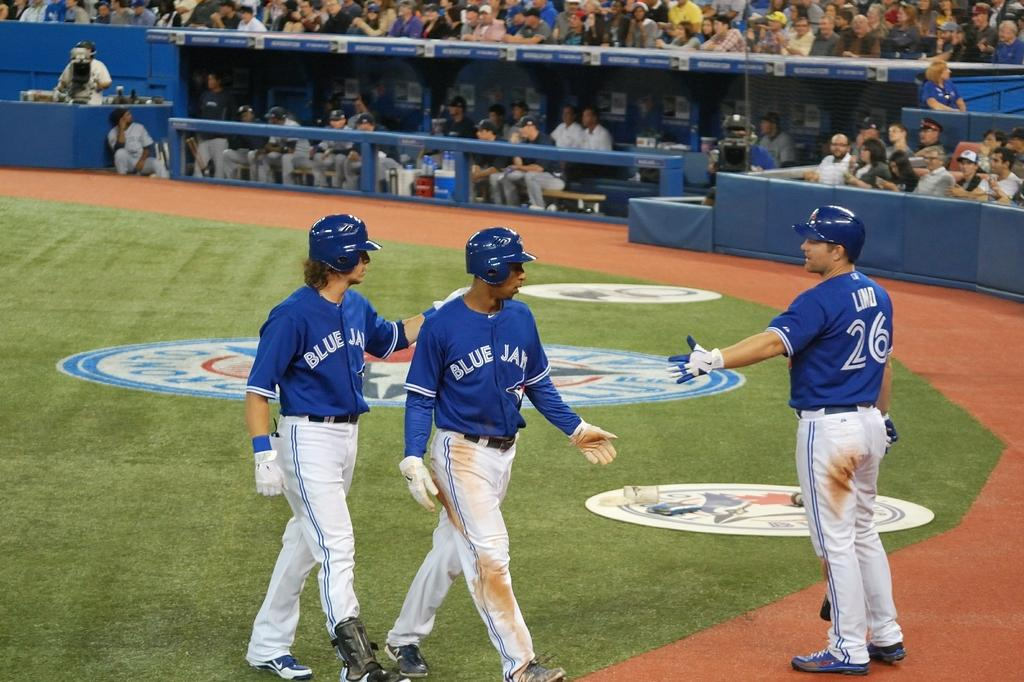<image>
Provide a brief description of the given image. Three sportsmen wearing blue tops, one of which bears the number 26. 